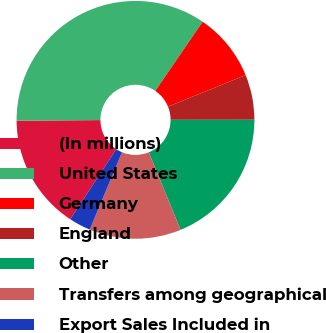Convert chart. <chart><loc_0><loc_0><loc_500><loc_500><pie_chart><fcel>(In millions)<fcel>United States<fcel>Germany<fcel>England<fcel>Other<fcel>Transfers among geographical<fcel>Export Sales Included in<nl><fcel>15.64%<fcel>34.67%<fcel>9.3%<fcel>6.13%<fcel>18.82%<fcel>12.47%<fcel>2.96%<nl></chart> 